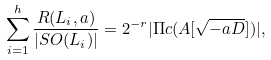Convert formula to latex. <formula><loc_0><loc_0><loc_500><loc_500>\sum _ { i = 1 } ^ { h } \frac { R ( L _ { i } , a ) } { | S O ( L _ { i } ) | } = 2 ^ { - r } | \Pi c ( A [ \sqrt { - a D } ] ) | ,</formula> 